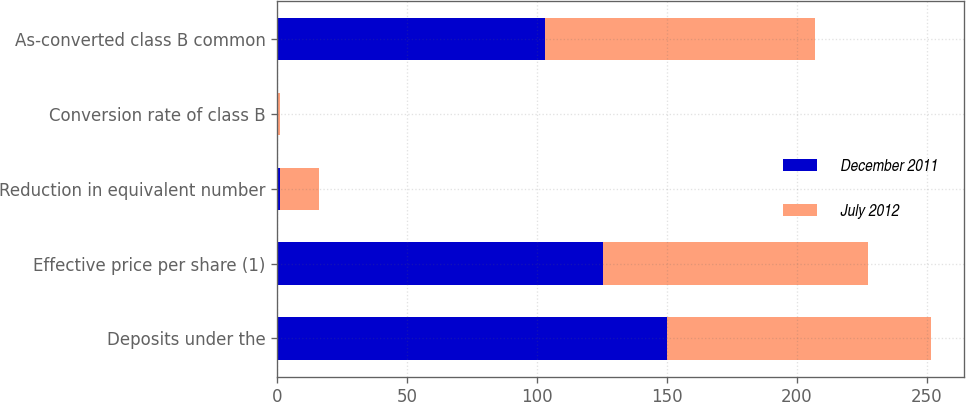Convert chart to OTSL. <chart><loc_0><loc_0><loc_500><loc_500><stacked_bar_chart><ecel><fcel>Deposits under the<fcel>Effective price per share (1)<fcel>Reduction in equivalent number<fcel>Conversion rate of class B<fcel>As-converted class B common<nl><fcel>December 2011<fcel>150<fcel>125.5<fcel>1<fcel>0.42<fcel>103<nl><fcel>July 2012<fcel>101.75<fcel>101.75<fcel>15<fcel>0.43<fcel>104<nl></chart> 